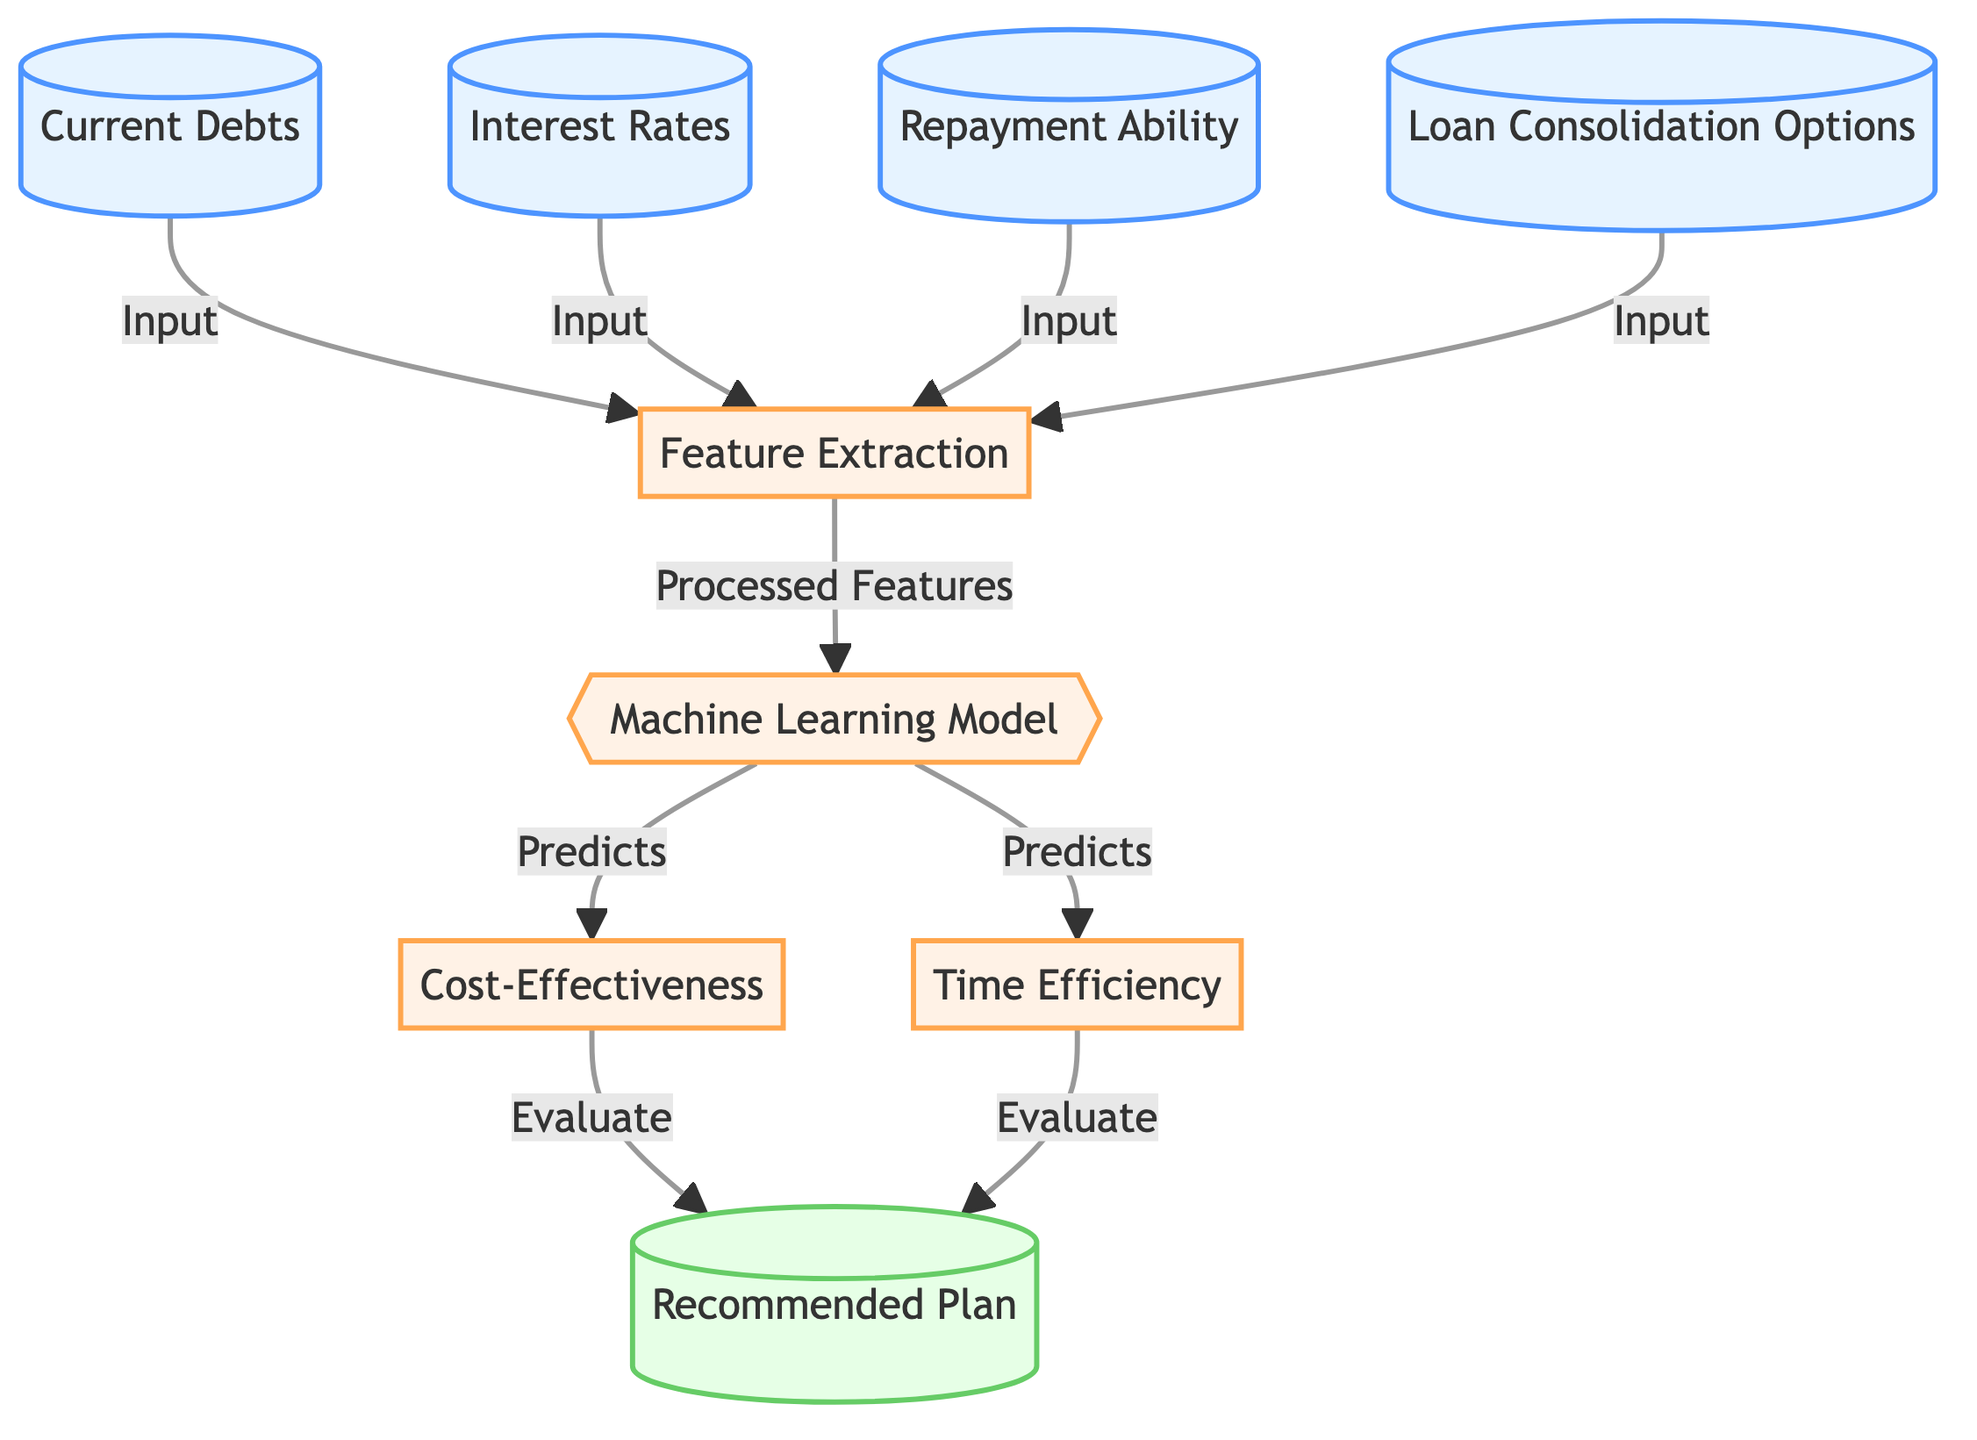What are the input nodes in this diagram? The input nodes are 1 (Current Debts), 2 (Interest Rates), 3 (Repayment Ability), and 4 (Loan Consolidation Options). They provide the initial data needed for the process.
Answer: Current Debts, Interest Rates, Repayment Ability, Loan Consolidation Options How many process nodes are in the diagram? The process nodes are 5 (Feature Extraction), 6 (Machine Learning Model), 7 (Cost-Effectiveness), and 8 (Time Efficiency), totaling four process nodes in the diagram.
Answer: 4 Which node directly outputs the recommended plan? The node that directly outputs the recommended plan is node 9, which is labeled as "Recommended Plan." It evaluates the results from Cost-Effectiveness and Time Efficiency nodes to provide the final output.
Answer: Recommended Plan What is the purpose of the 'Machine Learning Model' node? The 'Machine Learning Model' node processes the features extracted from the input nodes and predicts both cost-effectiveness and time efficiency for loan consolidation options. It plays a crucial role in determining the outputs.
Answer: Predicts cost-effectiveness and time efficiency How do 'Cost-Effectiveness' and 'Time Efficiency' contribute to the 'Recommended Plan'? Both 'Cost-Effectiveness' and 'Time Efficiency' nodes evaluate the predictions made by the 'Machine Learning Model' and feed their results into the 'Recommended Plan' node, which makes a final recommendation based on these evaluations. This means that the recommended plan is analyzed based on both factors, ensuring a comprehensive solution.
Answer: They evaluate and inform the Recommended Plan What happens to the inputs after 'Feature Extraction'? After 'Feature Extraction,' the processed features are sent to the 'Machine Learning Model' for further analysis. This is where the initial data from the inputs is transformed into a format that the model can use to make predictions.
Answer: Processed features go to Machine Learning Model How many input nodes are connected to the 'Feature Extraction' node? Four input nodes are connected to the 'Feature Extraction' node: Current Debts, Interest Rates, Repayment Ability, and Loan Consolidation Options, indicating a comprehensive analysis based on multiple inputs.
Answer: 4 What is the relationship between the 'Machine Learning Model' and the nodes 'Cost-Effectiveness' and 'Time Efficiency'? The 'Machine Learning Model' node predicts the values for both 'Cost-Effectiveness' and 'Time Efficiency' based on the processed features obtained from the input nodes. Thus, it serves as the primary analytical component that informs these subsequent calculations.
Answer: Predicts their values 